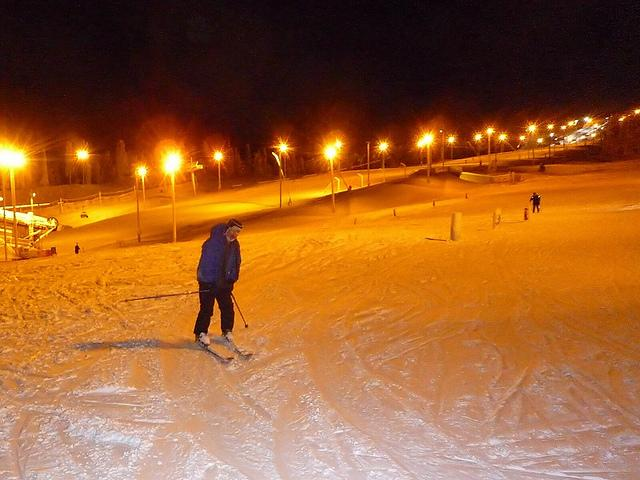Why is there so much orange in this image? Please explain your reasoning. orange lights. The lights are orange. 